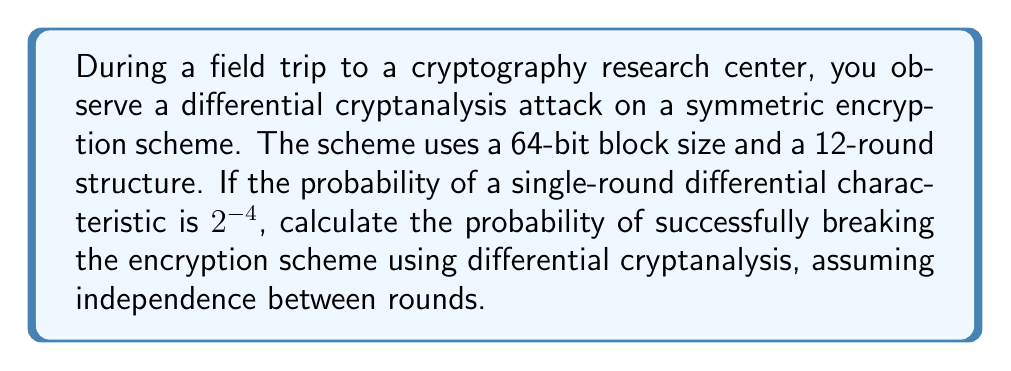What is the answer to this math problem? Let's approach this step-by-step:

1) In differential cryptanalysis, we analyze how differences in the input affect differences in the output across multiple rounds of the encryption process.

2) The probability of a single-round differential characteristic is given as $2^{-4}$.

3) For a 12-round structure, we need to calculate the probability of this characteristic holding true for all 12 rounds.

4) Assuming independence between rounds (which is a common simplification in cryptanalysis), we can multiply the probabilities:

   $$P(\text{12-round characteristic}) = (2^{-4})^{12}$$

5) Let's simplify this:
   
   $$P(\text{12-round characteristic}) = 2^{-4 \cdot 12} = 2^{-48}$$

6) This probability represents the chance of our chosen differential characteristic holding true for all 12 rounds.

7) In practice, to break the encryption scheme, we typically need about $2^n$ known plaintext-ciphertext pairs, where $n$ is the block size (64 in this case).

8) Therefore, the probability of successfully breaking the scheme is approximately:

   $$P(\text{success}) = 2^{-48} \cdot 2^{64} = 2^{16}$$

9) This can be interpreted as: for every $2^{16}$ attempts, we expect to break the scheme once.

10) To express this as a probability, we calculate:

    $$P(\text{success}) = \frac{1}{2^{-16}} = 2^{16} \approx 0.0015259$$
Answer: $2^{16}$ or approximately 0.0015259 